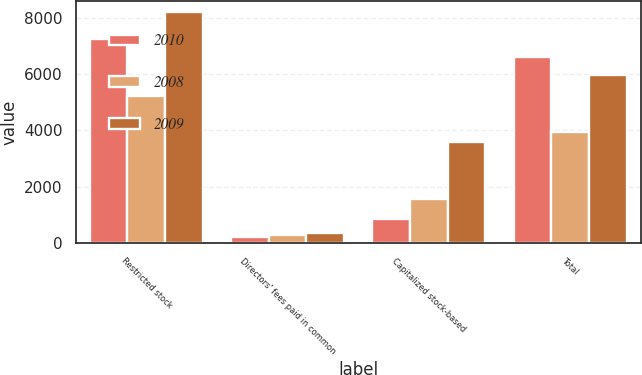Convert chart. <chart><loc_0><loc_0><loc_500><loc_500><stacked_bar_chart><ecel><fcel>Restricted stock<fcel>Directors' fees paid in common<fcel>Capitalized stock-based<fcel>Total<nl><fcel>2010<fcel>7236<fcel>231<fcel>852<fcel>6615<nl><fcel>2008<fcel>5227<fcel>279<fcel>1574<fcel>3932<nl><fcel>2009<fcel>8193<fcel>375<fcel>3606<fcel>5950<nl></chart> 